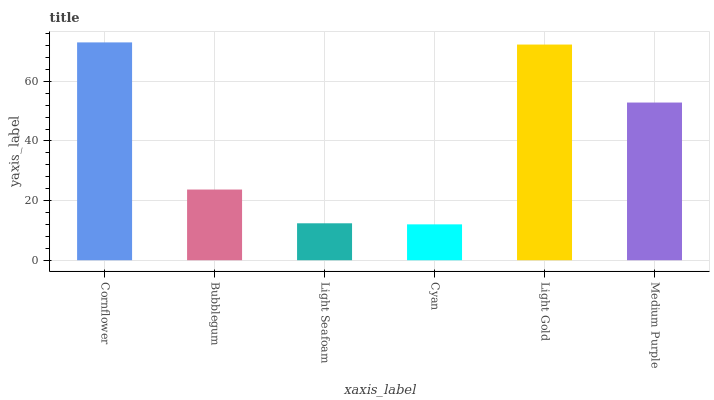Is Cyan the minimum?
Answer yes or no. Yes. Is Cornflower the maximum?
Answer yes or no. Yes. Is Bubblegum the minimum?
Answer yes or no. No. Is Bubblegum the maximum?
Answer yes or no. No. Is Cornflower greater than Bubblegum?
Answer yes or no. Yes. Is Bubblegum less than Cornflower?
Answer yes or no. Yes. Is Bubblegum greater than Cornflower?
Answer yes or no. No. Is Cornflower less than Bubblegum?
Answer yes or no. No. Is Medium Purple the high median?
Answer yes or no. Yes. Is Bubblegum the low median?
Answer yes or no. Yes. Is Cyan the high median?
Answer yes or no. No. Is Light Seafoam the low median?
Answer yes or no. No. 